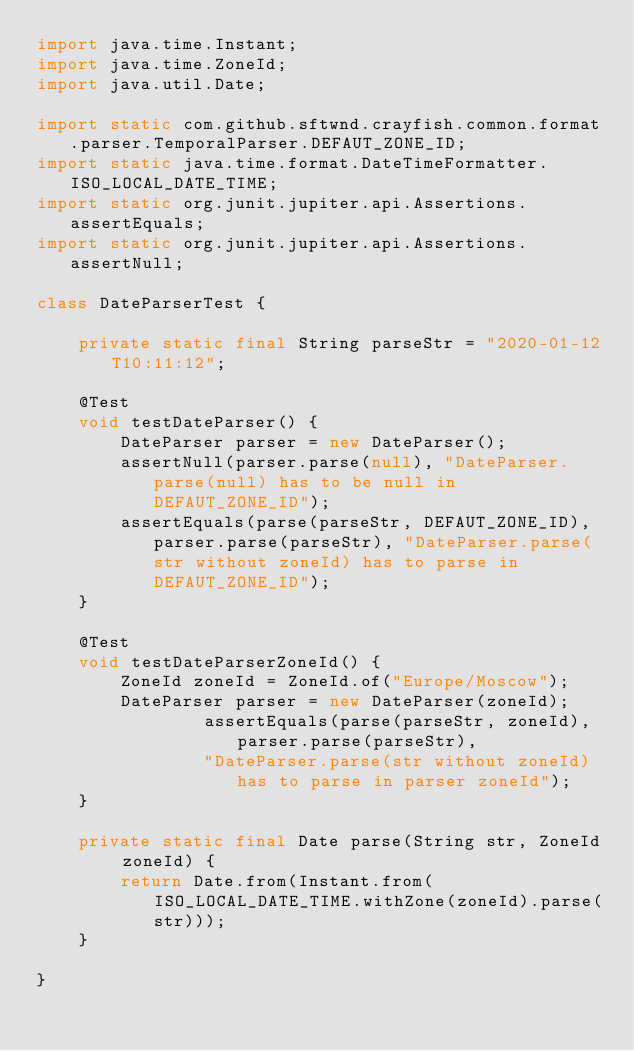<code> <loc_0><loc_0><loc_500><loc_500><_Java_>import java.time.Instant;
import java.time.ZoneId;
import java.util.Date;

import static com.github.sftwnd.crayfish.common.format.parser.TemporalParser.DEFAUT_ZONE_ID;
import static java.time.format.DateTimeFormatter.ISO_LOCAL_DATE_TIME;
import static org.junit.jupiter.api.Assertions.assertEquals;
import static org.junit.jupiter.api.Assertions.assertNull;

class DateParserTest {

    private static final String parseStr = "2020-01-12T10:11:12";

    @Test
    void testDateParser() {
        DateParser parser = new DateParser();
        assertNull(parser.parse(null), "DateParser.parse(null) has to be null in DEFAUT_ZONE_ID");
        assertEquals(parse(parseStr, DEFAUT_ZONE_ID), parser.parse(parseStr), "DateParser.parse(str without zoneId) has to parse in DEFAUT_ZONE_ID");
    }

    @Test
    void testDateParserZoneId() {
        ZoneId zoneId = ZoneId.of("Europe/Moscow");
        DateParser parser = new DateParser(zoneId);
                assertEquals(parse(parseStr, zoneId), parser.parse(parseStr),
                "DateParser.parse(str without zoneId) has to parse in parser zoneId");
    }

    private static final Date parse(String str, ZoneId zoneId) {
        return Date.from(Instant.from(ISO_LOCAL_DATE_TIME.withZone(zoneId).parse(str)));
    }

}</code> 